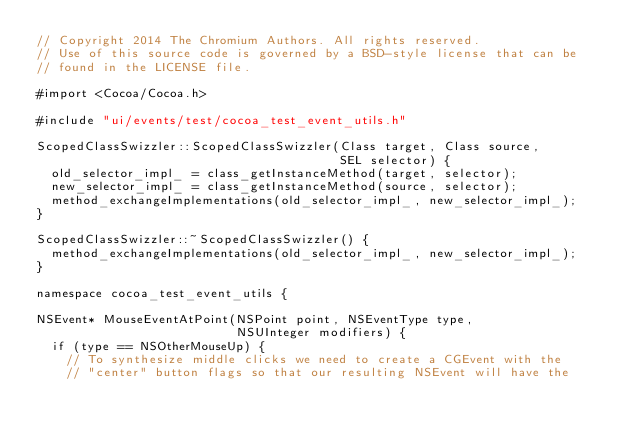Convert code to text. <code><loc_0><loc_0><loc_500><loc_500><_ObjectiveC_>// Copyright 2014 The Chromium Authors. All rights reserved.
// Use of this source code is governed by a BSD-style license that can be
// found in the LICENSE file.

#import <Cocoa/Cocoa.h>

#include "ui/events/test/cocoa_test_event_utils.h"

ScopedClassSwizzler::ScopedClassSwizzler(Class target, Class source,
                                         SEL selector) {
  old_selector_impl_ = class_getInstanceMethod(target, selector);
  new_selector_impl_ = class_getInstanceMethod(source, selector);
  method_exchangeImplementations(old_selector_impl_, new_selector_impl_);
}

ScopedClassSwizzler::~ScopedClassSwizzler() {
  method_exchangeImplementations(old_selector_impl_, new_selector_impl_);
}

namespace cocoa_test_event_utils {

NSEvent* MouseEventAtPoint(NSPoint point, NSEventType type,
                           NSUInteger modifiers) {
  if (type == NSOtherMouseUp) {
    // To synthesize middle clicks we need to create a CGEvent with the
    // "center" button flags so that our resulting NSEvent will have the</code> 